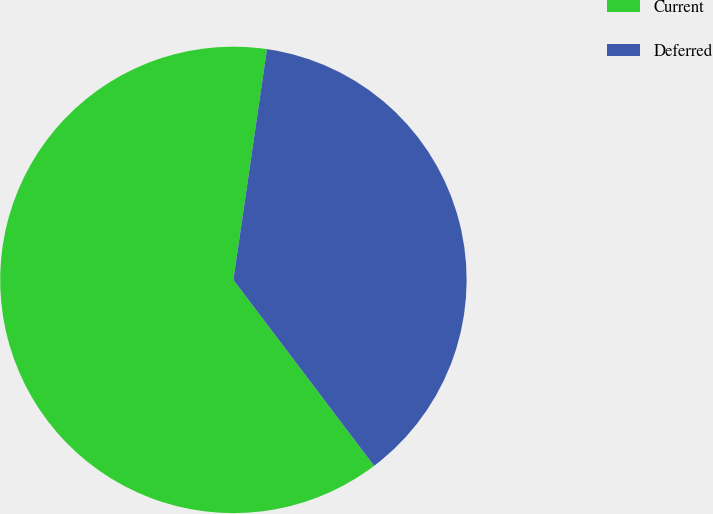Convert chart. <chart><loc_0><loc_0><loc_500><loc_500><pie_chart><fcel>Current<fcel>Deferred<nl><fcel>62.61%<fcel>37.39%<nl></chart> 